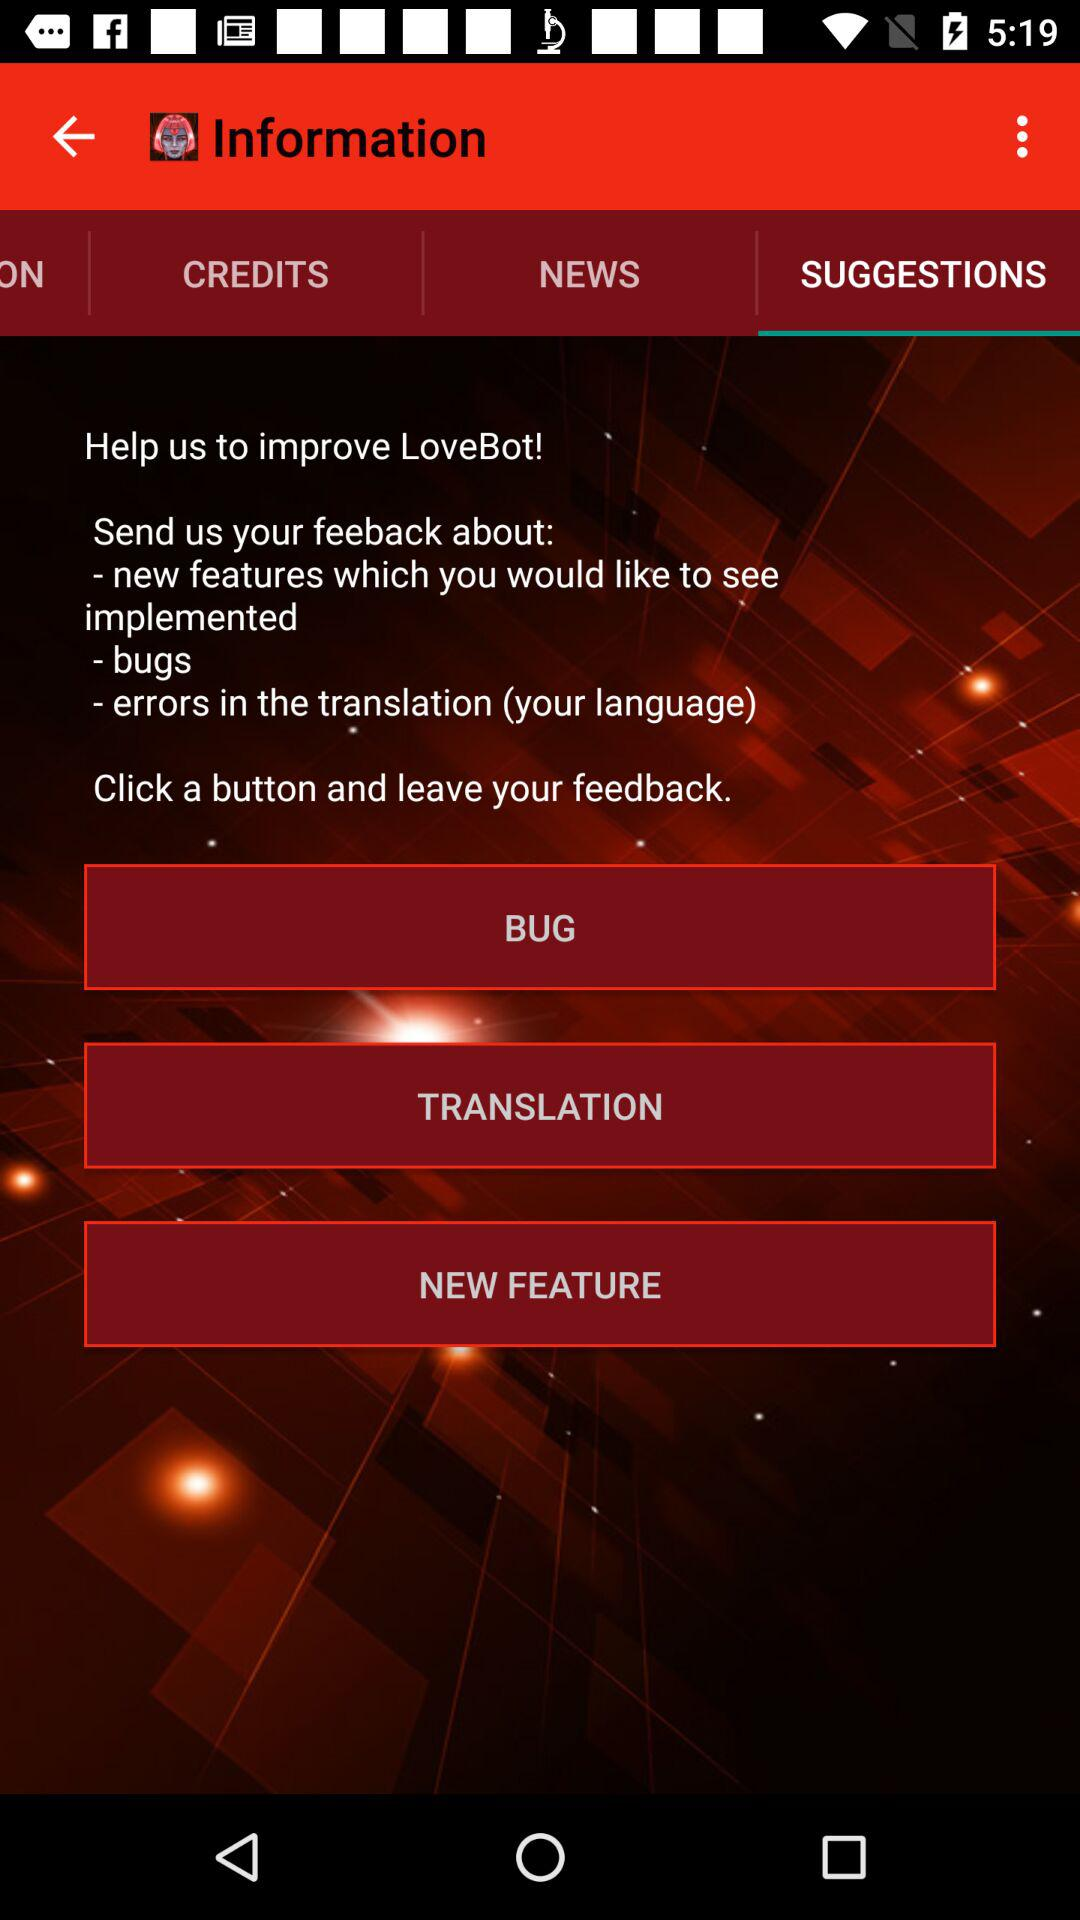Which language can this be translated into?
When the provided information is insufficient, respond with <no answer>. <no answer> 